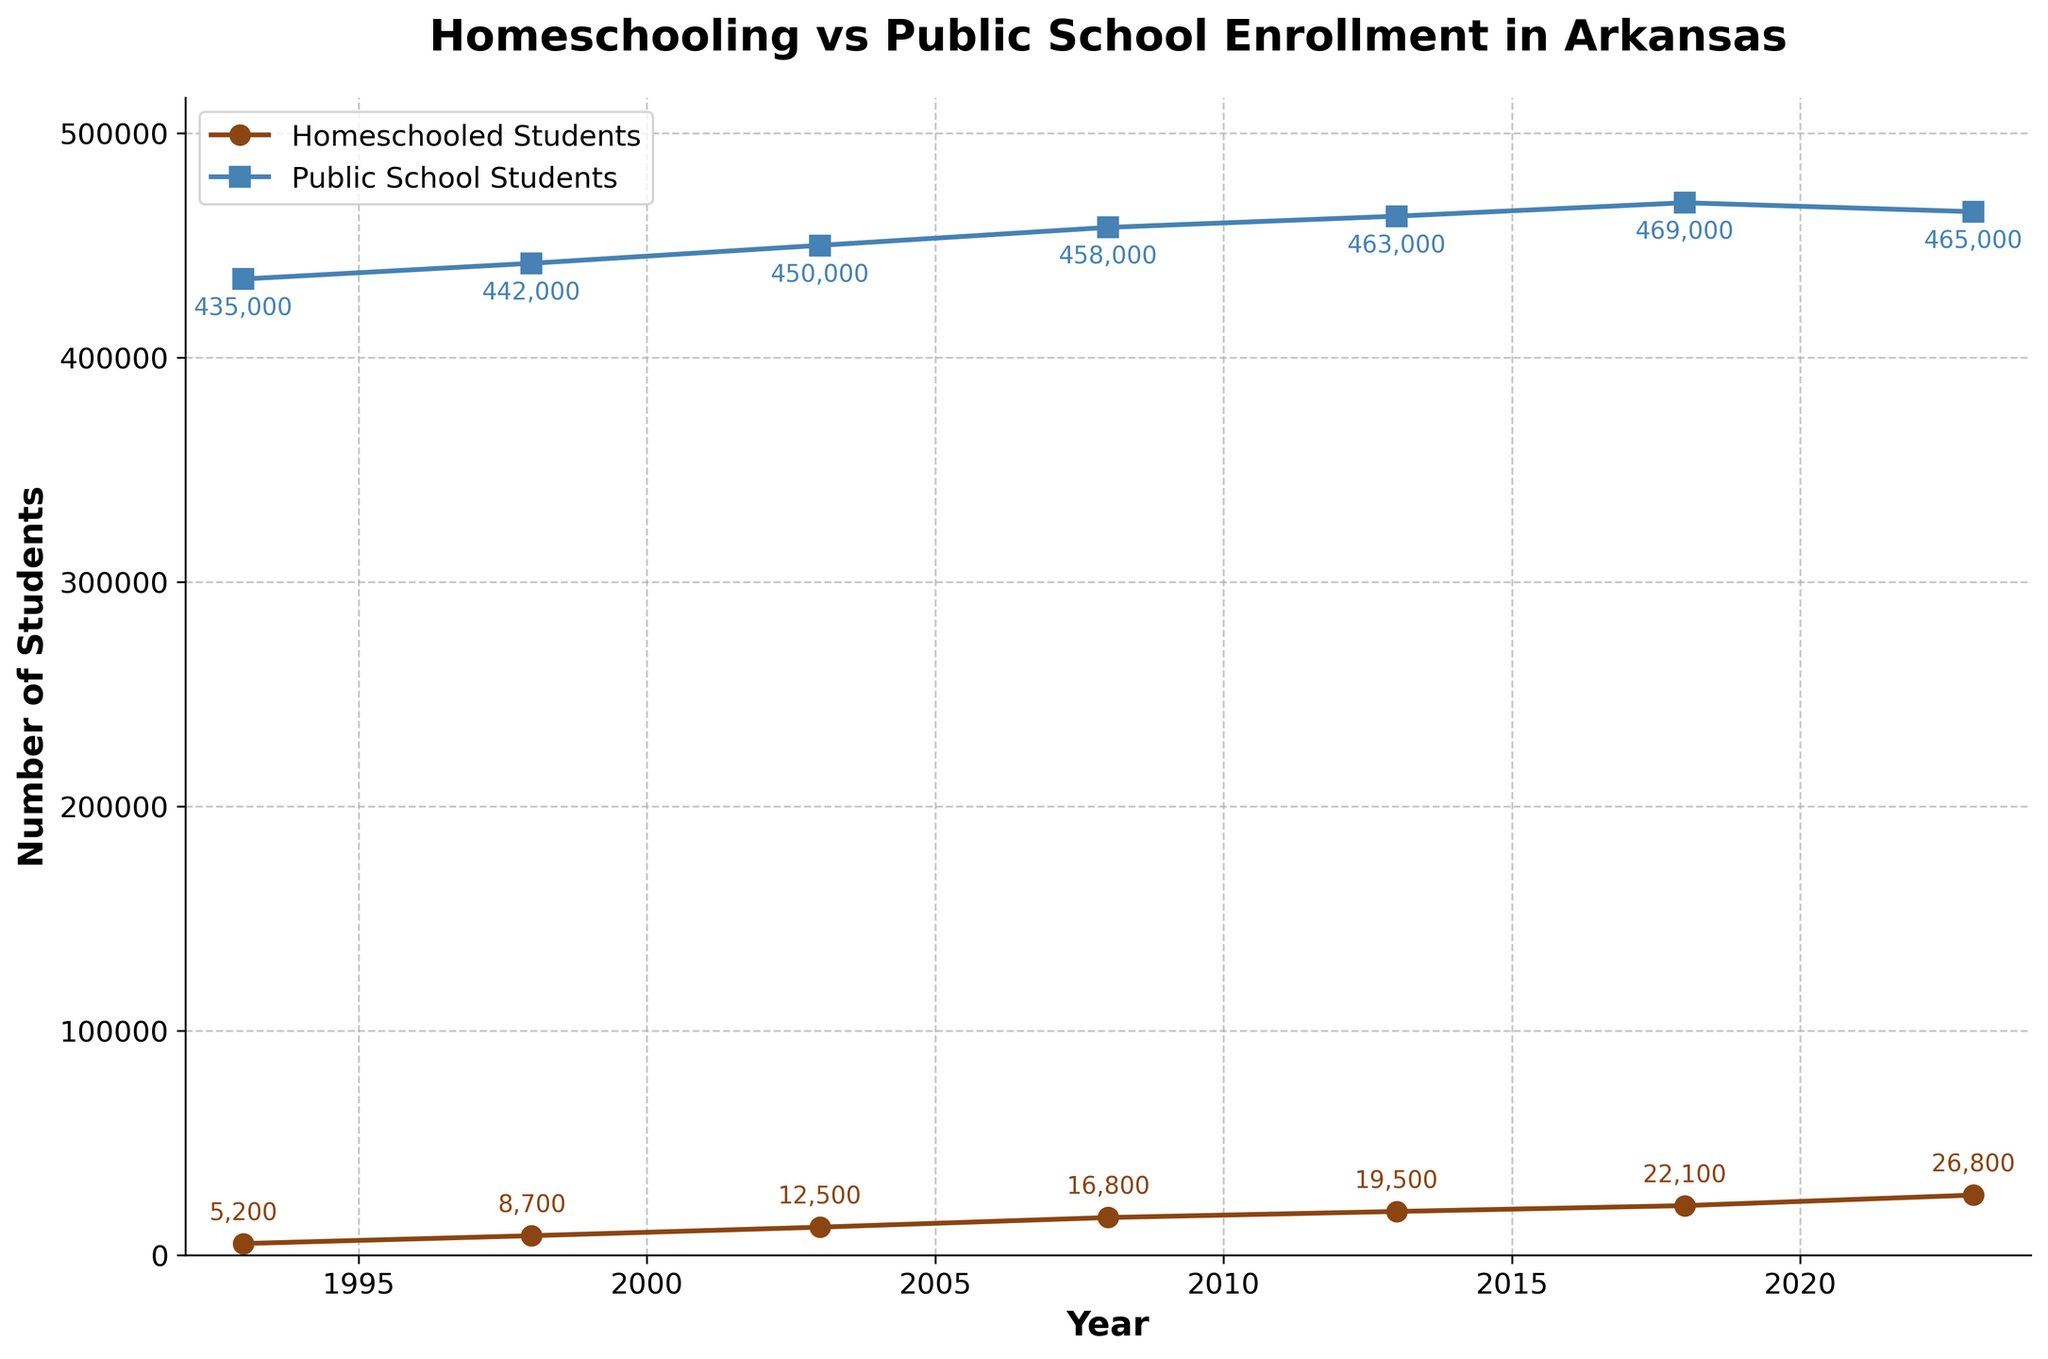Which year had the highest number of homeschooled students? Look at the plot and find the highest point on the line representing homeschooled students. Then refer to the x-axis to find the corresponding year.
Answer: 2023 How many more homeschooled students were there in 2023 compared to 1993? Find the number of homeschooled students in 2023 and in 1993 from the plot and then subtract the 1993 value from the 2023 value. Homeschooled students in 2023 are 26,800 and in 1993 are 5,200. 26,800 - 5,200 = 21,600
Answer: 21,600 Which year showed the smallest difference between homeschooled and public school students? Calculate the difference between homeschooled and public school students for each year and identify which year has the smallest difference from the plot. For 1993: 435,000 - 5,200; for 1998: 442,000 - 8,700; for 2003: 450,000 - 12,500; for 2008: 458,000 - 16,800; for 2013: 463,000 - 19,500; for 2018: 469,000 - 22,100; for 2023: 465,000 - 26,800. The year 2023 has the smallest difference.
Answer: 2023 Was there any year where the number of public school students decreased from the previous year? Check the values of public school students for each year and see if there is any year where the number is less than the year before. The plot shows a decrease from 2018 to 2023 (469,000 to 465,000).
Answer: Yes In what year did homeschooled students exceed 10,000? Look at the plot and identify the year at which the homeschooled student line crosses the 10,000 mark on the y-axis. The value exceeds 10,000 between 1998 and 2003. Checking these two values, it's in 2003.
Answer: 2003 By how much did public school enrollment increase from 1993 to 2013? Determine the public school enrollment numbers from the plot for 1993 and 2013 and subtract the earlier value from the later value. For 1993: 435,000, for 2013: 463,000. Then, 463,000 - 435,000 = 28,000.
Answer: 28,000 Which type of schooling (homeschooled or public) had a more significant percentage increase from 1993 to 2023? Calculate the percentage increase for both homeschooled and public school students using the plot values. For homeschooled: ((26,800 - 5,200) / 5,200) * 100 = 415.38%. For public: ((465,000 - 435,000) / 435,000) * 100 = 6.9%. Homeschooled has a more significant percentage increase.
Answer: Homeschooled What is the average number of homeschooled students over the entire period shown? Sum the total number of homeschooled students for all years (5200 + 8700 + 12500 + 16800 + 19500 + 22100 + 26800) and divide by the number of data points (7 years). The sum is 112,600, so the average is 112,600 / 7 = 16,085.71.
Answer: 16,085.71 